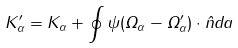<formula> <loc_0><loc_0><loc_500><loc_500>K _ { \alpha } ^ { \prime } = K _ { \alpha } + \oint \psi ( { \Omega } _ { \alpha } - { \Omega } _ { \alpha } ^ { \prime } ) \cdot \hat { n } d a</formula> 